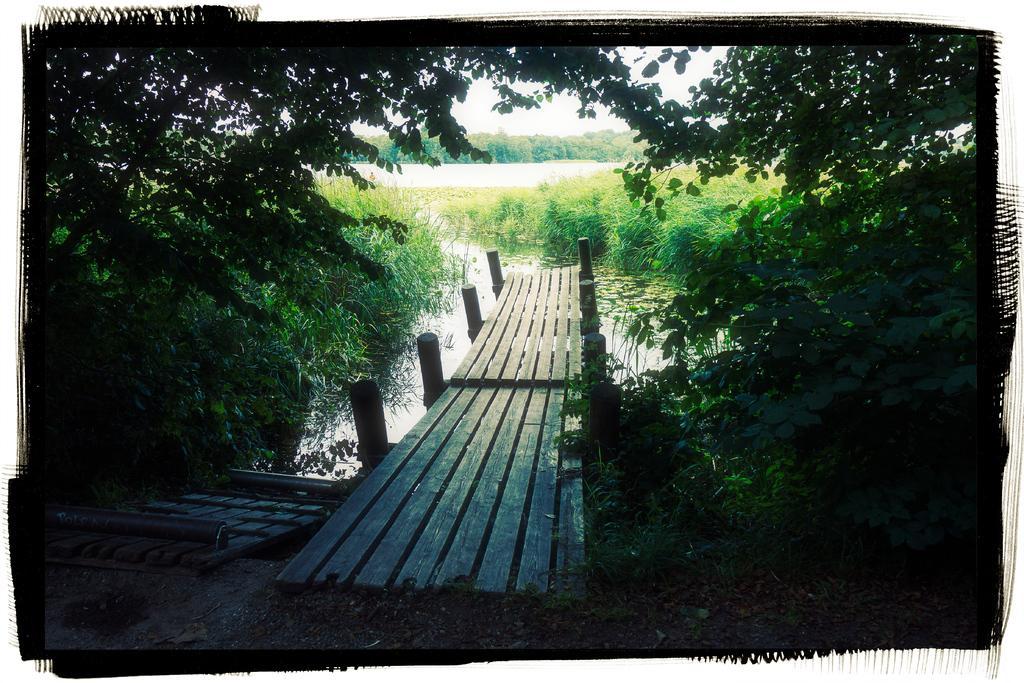How would you summarize this image in a sentence or two? In the center of the image there is a wooden bridge. There are poles. Beside the bridge there is some object. At the bottom of the image there is water. There is grass on the surface. In the background of the image there are trees and sky. 